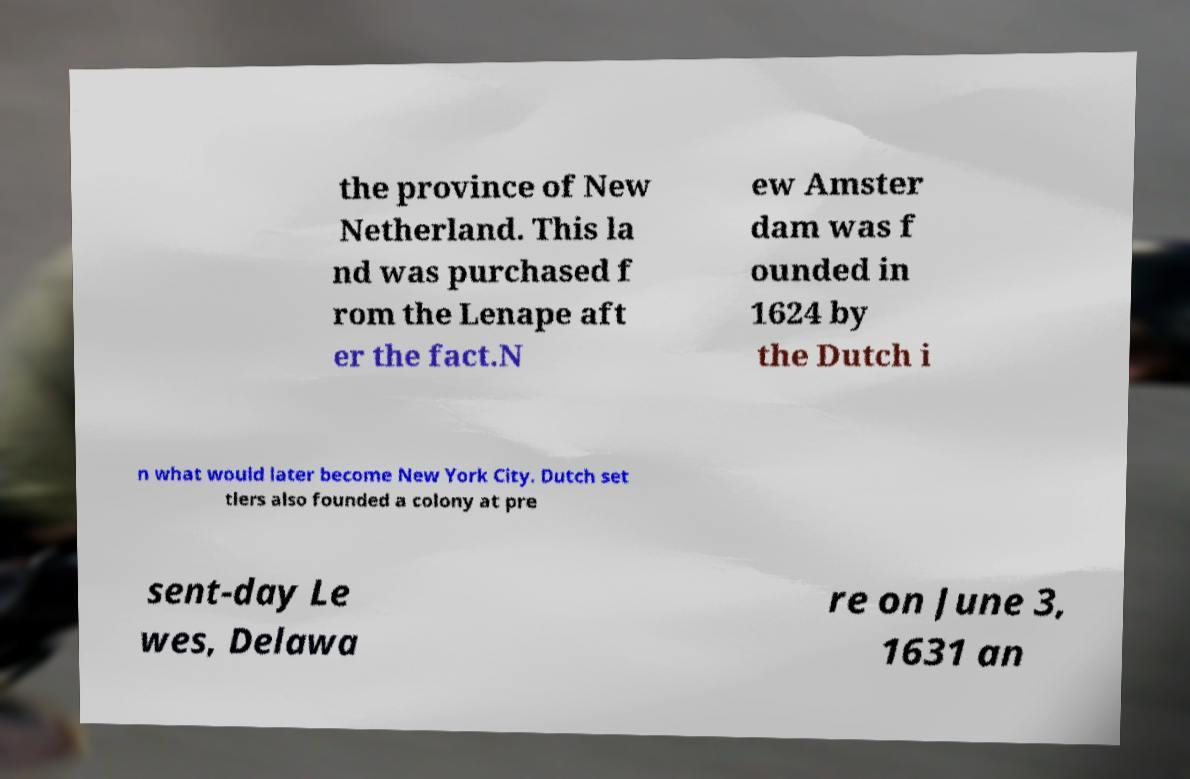I need the written content from this picture converted into text. Can you do that? the province of New Netherland. This la nd was purchased f rom the Lenape aft er the fact.N ew Amster dam was f ounded in 1624 by the Dutch i n what would later become New York City. Dutch set tlers also founded a colony at pre sent-day Le wes, Delawa re on June 3, 1631 an 